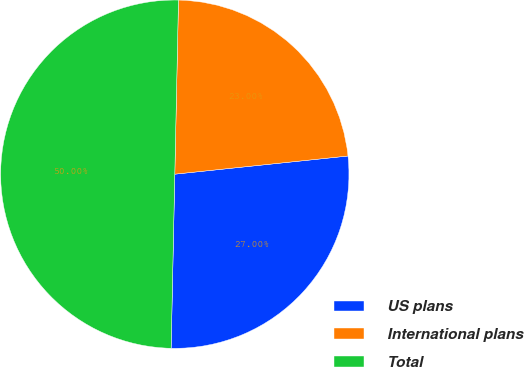<chart> <loc_0><loc_0><loc_500><loc_500><pie_chart><fcel>US plans<fcel>International plans<fcel>Total<nl><fcel>27.0%<fcel>23.0%<fcel>50.0%<nl></chart> 